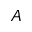Convert formula to latex. <formula><loc_0><loc_0><loc_500><loc_500>A</formula> 